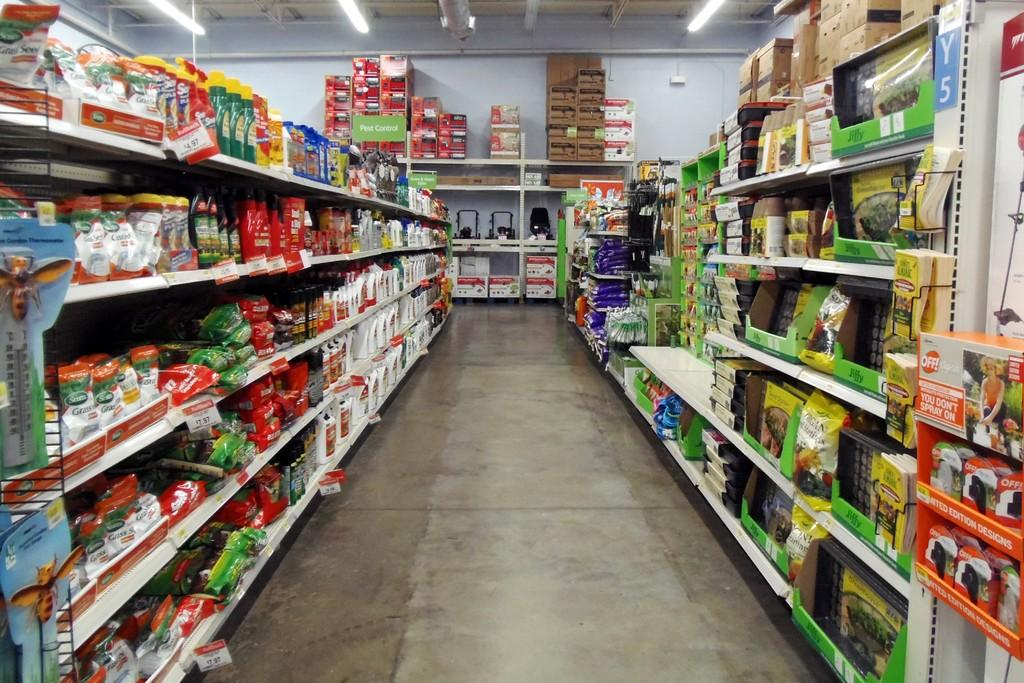<image>
Render a clear and concise summary of the photo. a store interior with shelves of goods for things like JIFFY 